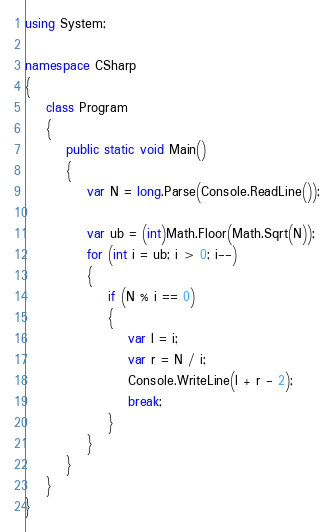Convert code to text. <code><loc_0><loc_0><loc_500><loc_500><_C#_>using System;

namespace CSharp
{
    class Program
    {
        public static void Main()
        {
            var N = long.Parse(Console.ReadLine());

            var ub = (int)Math.Floor(Math.Sqrt(N));
            for (int i = ub; i > 0; i--)
            {
                if (N % i == 0)
                {
                    var l = i;
                    var r = N / i;
                    Console.WriteLine(l + r - 2);
                    break;
                }
            }
        }
    }
}
</code> 